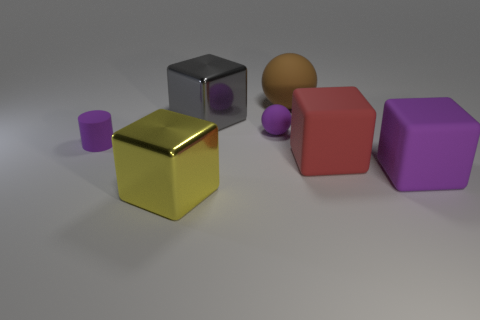Could you describe the texture of the objects and the surface on which they rest? The objects display a range of textures from what appears to be reflective and smooth on the gray cube, to matte and slightly rough on the red and purple objects. The surface upon which they rest seems to have a satin finish, with a subtle sheen that contrasts with the texture of the objects. 